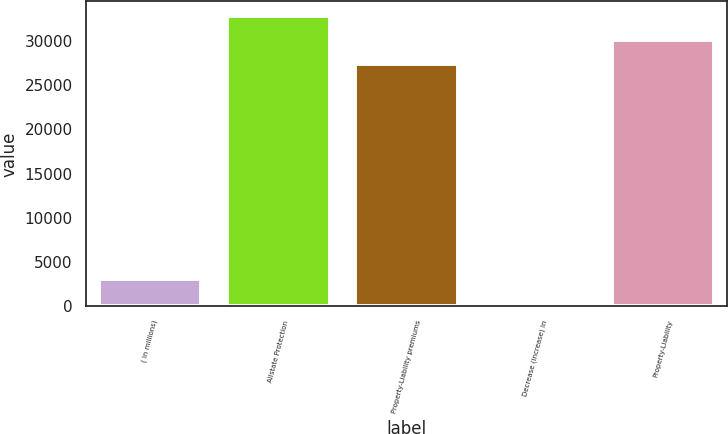<chart> <loc_0><loc_0><loc_500><loc_500><bar_chart><fcel>( in millions)<fcel>Allstate Protection<fcel>Property-Liability premiums<fcel>Decrease (increase) in<fcel>Property-Liability<nl><fcel>3071.2<fcel>32803.4<fcel>27369<fcel>354<fcel>30086.2<nl></chart> 